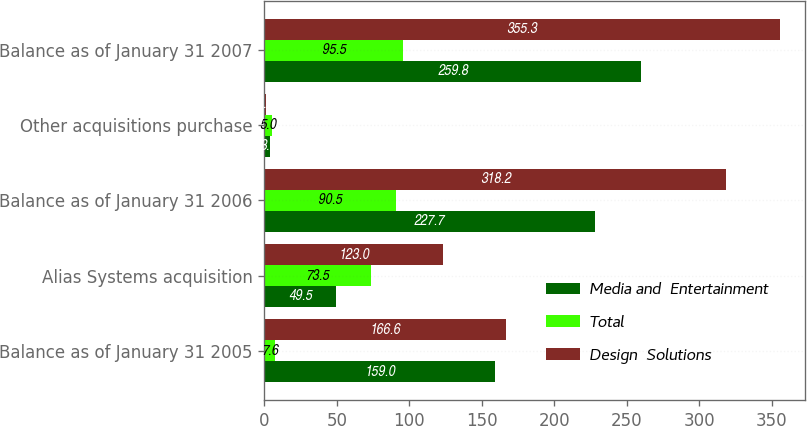<chart> <loc_0><loc_0><loc_500><loc_500><stacked_bar_chart><ecel><fcel>Balance as of January 31 2005<fcel>Alias Systems acquisition<fcel>Balance as of January 31 2006<fcel>Other acquisitions purchase<fcel>Balance as of January 31 2007<nl><fcel>Media and  Entertainment<fcel>159<fcel>49.5<fcel>227.7<fcel>3.8<fcel>259.8<nl><fcel>Total<fcel>7.6<fcel>73.5<fcel>90.5<fcel>5<fcel>95.5<nl><fcel>Design  Solutions<fcel>166.6<fcel>123<fcel>318.2<fcel>1.2<fcel>355.3<nl></chart> 